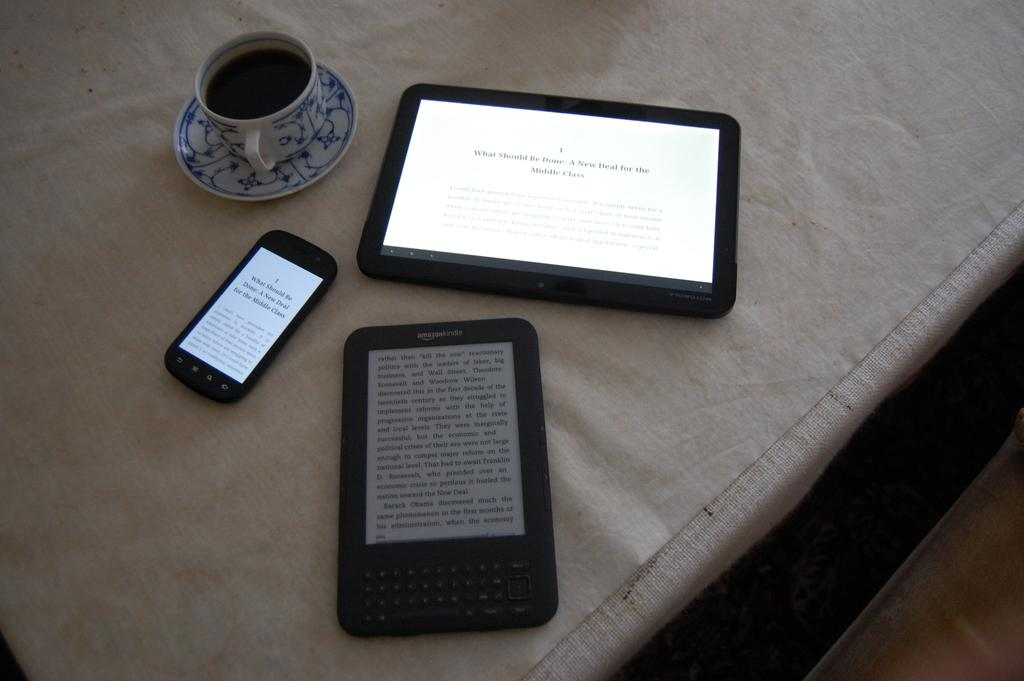What is the main structure in the image? There is a platform in the image. What is placed on the platform? There is a cloth on the platform. What is the liquid-holding object in the image? There is a cup with liquid in the image. What is the saucer used for in the image? The saucer is likely used to hold the cup or catch any spills. What type of items are considered gadgets in the image? The specific gadgets are not mentioned, but they are present in the image. What can be seen on the right side of the image? There is an object on the right side of the image. What type of wine is being served on the platform in the image? There is no wine present in the image; it only shows a cup with liquid, a saucer, and a cloth on a platform. 